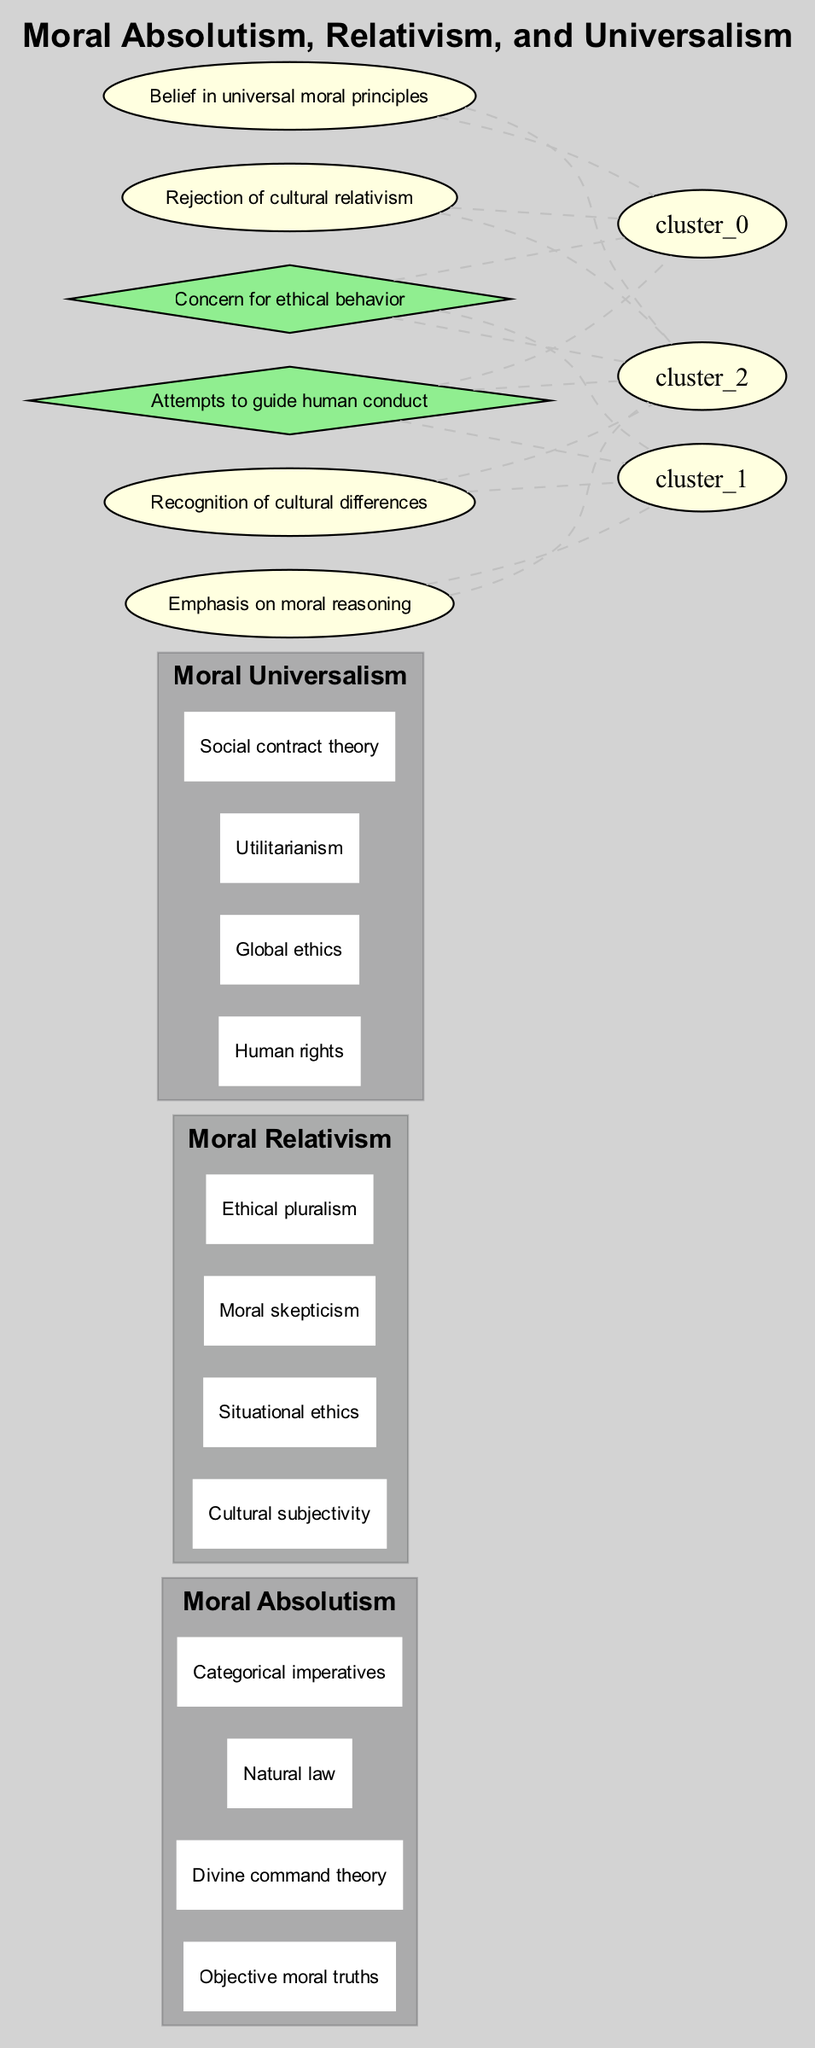What are the elements of Moral Absolutism? The diagram indicates that the elements of Moral Absolutism include "Objective moral truths," "Divine command theory," "Natural law," and "Categorical imperatives." These are listed within the box representing Moral Absolutism.
Answer: Objective moral truths, Divine command theory, Natural law, Categorical imperatives What intersection elements are shared between Moral Absolutism and Moral Universalism? The diagram shows that the intersection between Moral Absolutism and Moral Universalism contains "Belief in universal moral principles" and "Rejection of cultural relativism." These elements represent shared beliefs between the two sets.
Answer: Belief in universal moral principles, Rejection of cultural relativism How many elements are in the set of Moral Relativism? By counting the number of elements listed in the Moral Relativism box, we find four elements: "Cultural subjectivity," "Situational ethics," "Moral skepticism," and "Ethical pluralism."
Answer: Four What does the intersection of all three moral theories represent? The intersection of all three sets (Moral Absolutism, Moral Relativism, and Moral Universalism) is labeled with "Concern for ethical behavior" and "Attempts to guide human conduct," indicating a common aim across these theories despite their differences.
Answer: Concern for ethical behavior, Attempts to guide human conduct What specific focus is noted in the intersection of Moral Relativism and Moral Universalism? The intersection between Moral Relativism and Moral Universalism emphasizes "Recognition of cultural differences" and "Emphasis on moral reasoning," highlighting the importance of understanding different moral perspectives while promoting ethical reasoning.
Answer: Recognition of cultural differences, Emphasis on moral reasoning How many distinct sets are represented in the diagram? The diagram clearly shows three distinct sets: Moral Absolutism, Moral Relativism, and Moral Universalism, each represented by a different colored box.
Answer: Three What is the primary theme represented in the intersection of Moral Absolutism and Moral Universalism? The primary theme in the intersection of these two moral theories is centered around the belief in universal moral principles and the rejection of cultural relativism, indicating a focus on consistent ethical standards regardless of cultural context.
Answer: Belief in universal moral principles, Rejection of cultural relativism Which theory features elements relating to human rights? The diagram indicates that elements relating to human rights are found within the set of Moral Universalism, emphasizing a broader moral framework that transcends cultural specifics.
Answer: Moral Universalism What color scheme is used for the Moral Relativism set in the diagram? The set representing Moral Relativism is filled with a color that corresponds to the color defined for that specific subgraph in the diagram, which appears distinct from the others due to its unique color blend.
Answer: Unique color blend for Moral Relativism 